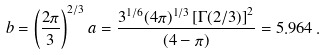Convert formula to latex. <formula><loc_0><loc_0><loc_500><loc_500>b = \left ( \frac { 2 \pi } { 3 } \right ) ^ { 2 / 3 } a = \frac { 3 ^ { 1 / 6 } ( 4 \pi ) ^ { 1 / 3 } \left [ \Gamma ( 2 / 3 ) \right ] ^ { 2 } } { ( 4 - \pi ) } = 5 . 9 6 4 \, .</formula> 